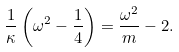<formula> <loc_0><loc_0><loc_500><loc_500>\frac { 1 } { \kappa } \left ( \omega ^ { 2 } - \frac { 1 } { 4 } \right ) = \frac { \omega ^ { 2 } } { m } - 2 .</formula> 